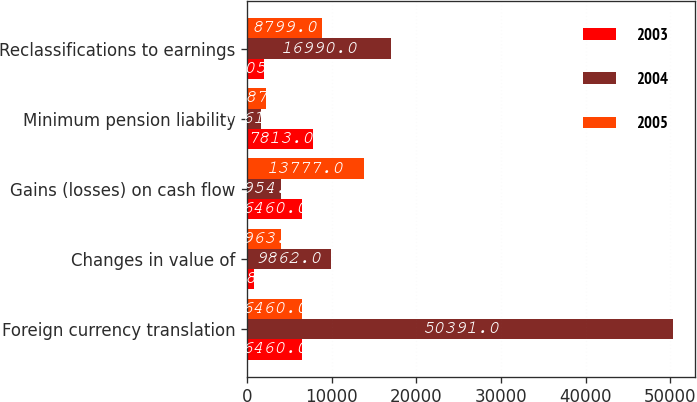<chart> <loc_0><loc_0><loc_500><loc_500><stacked_bar_chart><ecel><fcel>Foreign currency translation<fcel>Changes in value of<fcel>Gains (losses) on cash flow<fcel>Minimum pension liability<fcel>Reclassifications to earnings<nl><fcel>2003<fcel>6460<fcel>838<fcel>6460<fcel>7813<fcel>2005<nl><fcel>2004<fcel>50391<fcel>9862<fcel>3954<fcel>1661<fcel>16990<nl><fcel>2005<fcel>6460<fcel>3963<fcel>13777<fcel>2187<fcel>8799<nl></chart> 